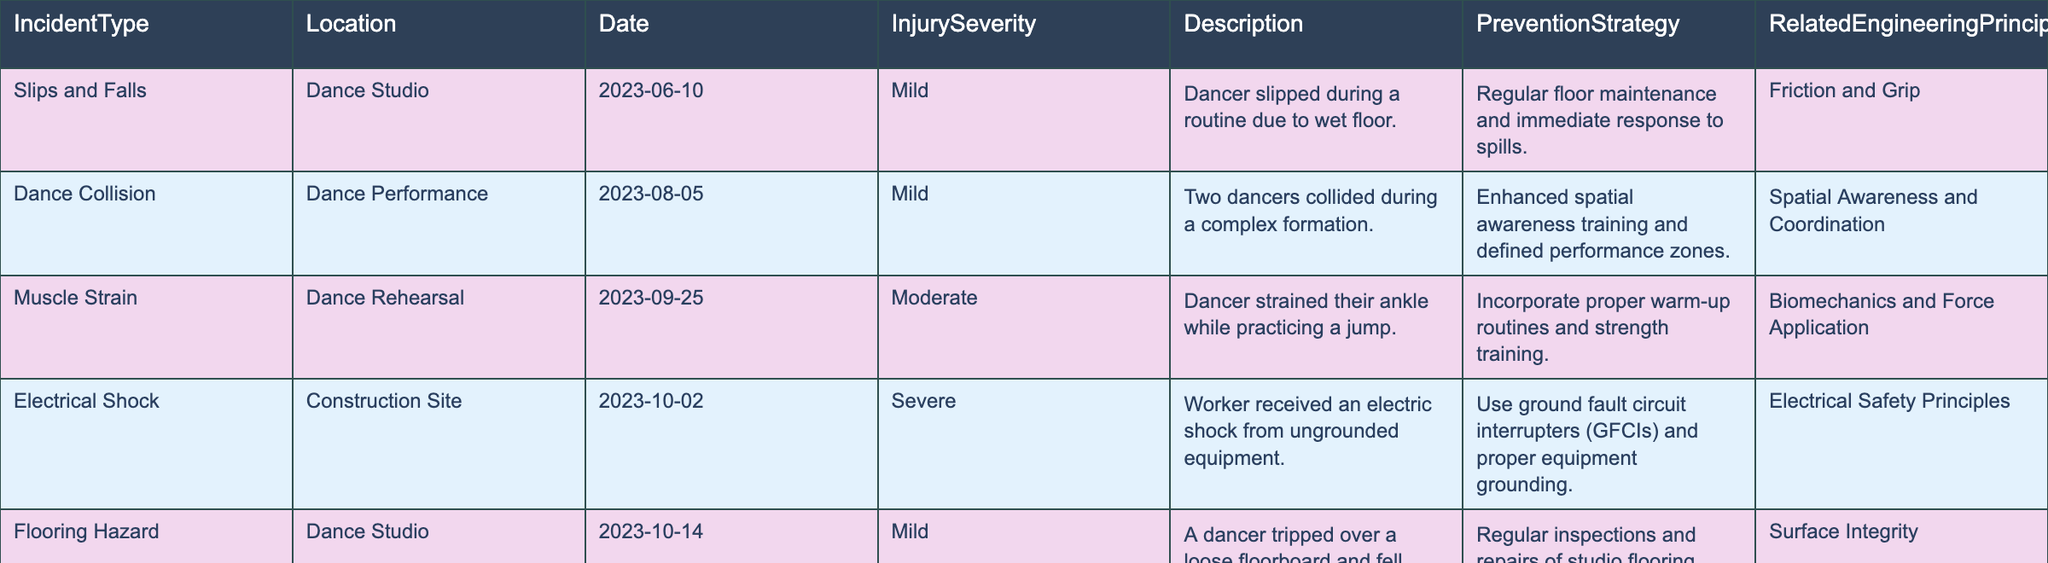What type of injury was reported during the Dance Performance on August 5, 2023? The table lists the injury severity and description for incidents. For the Dance Performance on August 5, 2023, the incident type recorded is "Dance Collision," and the injury severity is "Mild."
Answer: Mild How many severe incidents are listed in the table? To find the number of severe incidents, we need to count the entries where the Injury Severity is "Severe." There are two incidents in total marked as severe: one from the Construction Site and one from the Dance Studio.
Answer: 2 What is the prevention strategy for the electrical shock incident? The prevention strategy is stated in the table under the prevention strategy column for the entry related to the electrical shock incident on October 2, 2023. It states "Use ground fault circuit interrupters (GFCIs) and proper equipment grounding."
Answer: Use ground fault circuit interrupters (GFCIs) and proper equipment grounding Which incident occurred in the Dance Studio? The table shows several incidents. The incidents "Slips and Falls" and "Flooring Hazard" occurring in the Dance Studio are listed. These are notations of the locations noted in the table.
Answer: Slips and Falls, Flooring Hazard What is the average injury severity level across all incidents? The table classifies injury severity as Mild, Moderate, or Severe. We can assign values (Mild=1, Moderate=2, Severe=3) and average them. Counting the incidents, we have 5 mild, 1 moderate, and 2 severe incidents: (5*1 + 1*2 + 2*3) / 8 = 2. This gives an average severity level of 2, which corresponds to Moderate.
Answer: Moderate Was there any incident reported due to inadequate visibility? The table includes an incident on October 22, 2023, under "Lighting Issues" where inadequate stage lighting caused a dancer to misstep. Therefore, the answer is yes, there was an incident related to visibility.
Answer: Yes What was the date of the muscle strain incident? According to the table, the muscle strain incident occurred on September 25, 2023, as specified in the Date column for the "Muscle Strain" entry.
Answer: September 25, 2023 Which prevention strategy is shared by the slips and falls and flooring hazard incidents? Looking at the Prevention Strategy column for both "Slips and Falls" and "Flooring Hazard", both incidents have strategies related to frequent checks on the flooring condition, implying maintenance of flooring prevents such accidents.
Answer: Regular inspections and repairs of studio flooring 